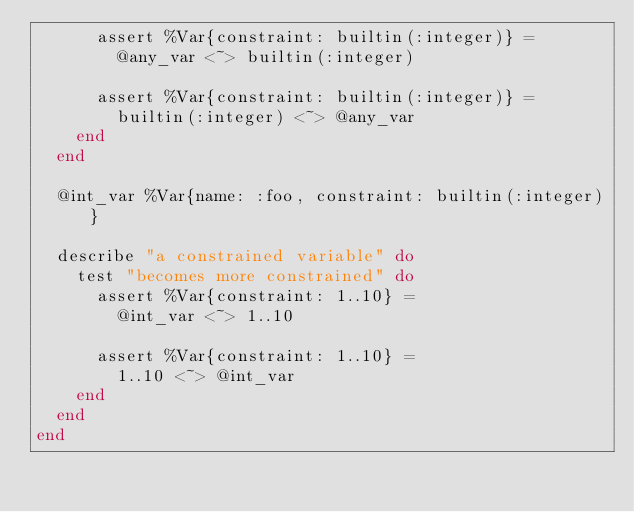<code> <loc_0><loc_0><loc_500><loc_500><_Elixir_>      assert %Var{constraint: builtin(:integer)} =
        @any_var <~> builtin(:integer)

      assert %Var{constraint: builtin(:integer)} =
        builtin(:integer) <~> @any_var
    end
  end

  @int_var %Var{name: :foo, constraint: builtin(:integer)}

  describe "a constrained variable" do
    test "becomes more constrained" do
      assert %Var{constraint: 1..10} =
        @int_var <~> 1..10

      assert %Var{constraint: 1..10} =
        1..10 <~> @int_var
    end
  end
end
</code> 